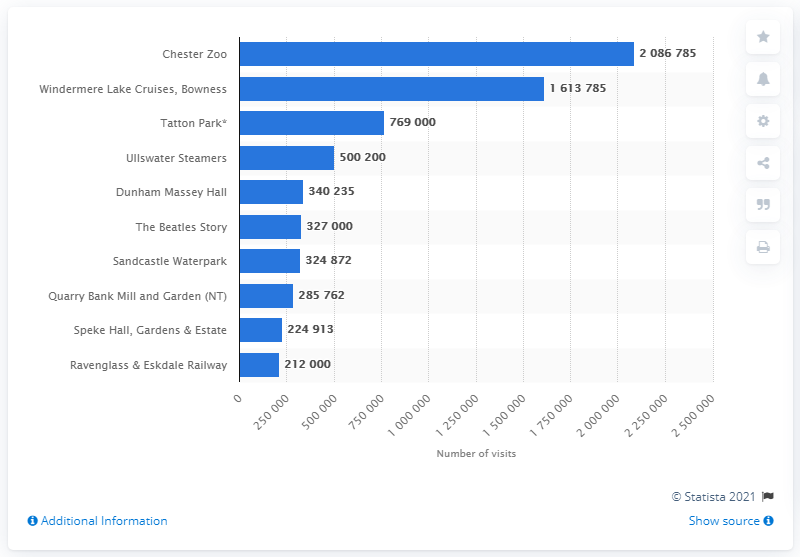Identify some key points in this picture. In 2019, a total of 2,086,785 visitors went to Chester Zoo. According to the North West region's statistics for 2019, Chester Zoo was the most visited paid attraction. 